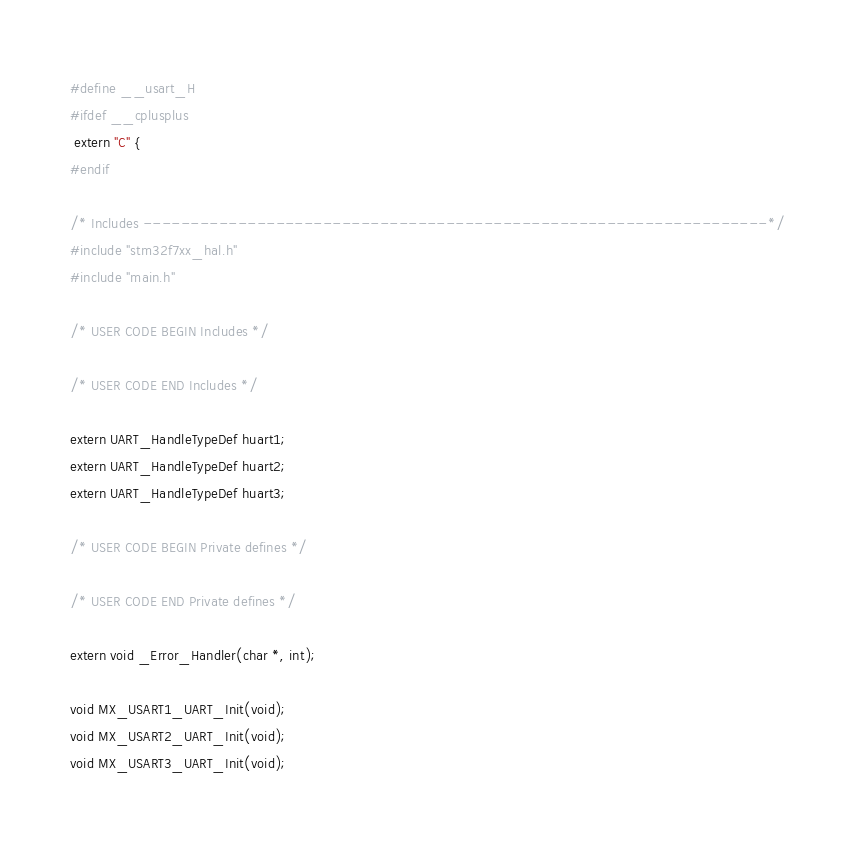<code> <loc_0><loc_0><loc_500><loc_500><_C_>#define __usart_H
#ifdef __cplusplus
 extern "C" {
#endif

/* Includes ------------------------------------------------------------------*/
#include "stm32f7xx_hal.h"
#include "main.h"

/* USER CODE BEGIN Includes */

/* USER CODE END Includes */

extern UART_HandleTypeDef huart1;
extern UART_HandleTypeDef huart2;
extern UART_HandleTypeDef huart3;

/* USER CODE BEGIN Private defines */

/* USER CODE END Private defines */

extern void _Error_Handler(char *, int);

void MX_USART1_UART_Init(void);
void MX_USART2_UART_Init(void);
void MX_USART3_UART_Init(void);
</code> 